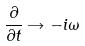Convert formula to latex. <formula><loc_0><loc_0><loc_500><loc_500>\frac { \partial } { \partial t } \rightarrow - i \omega</formula> 